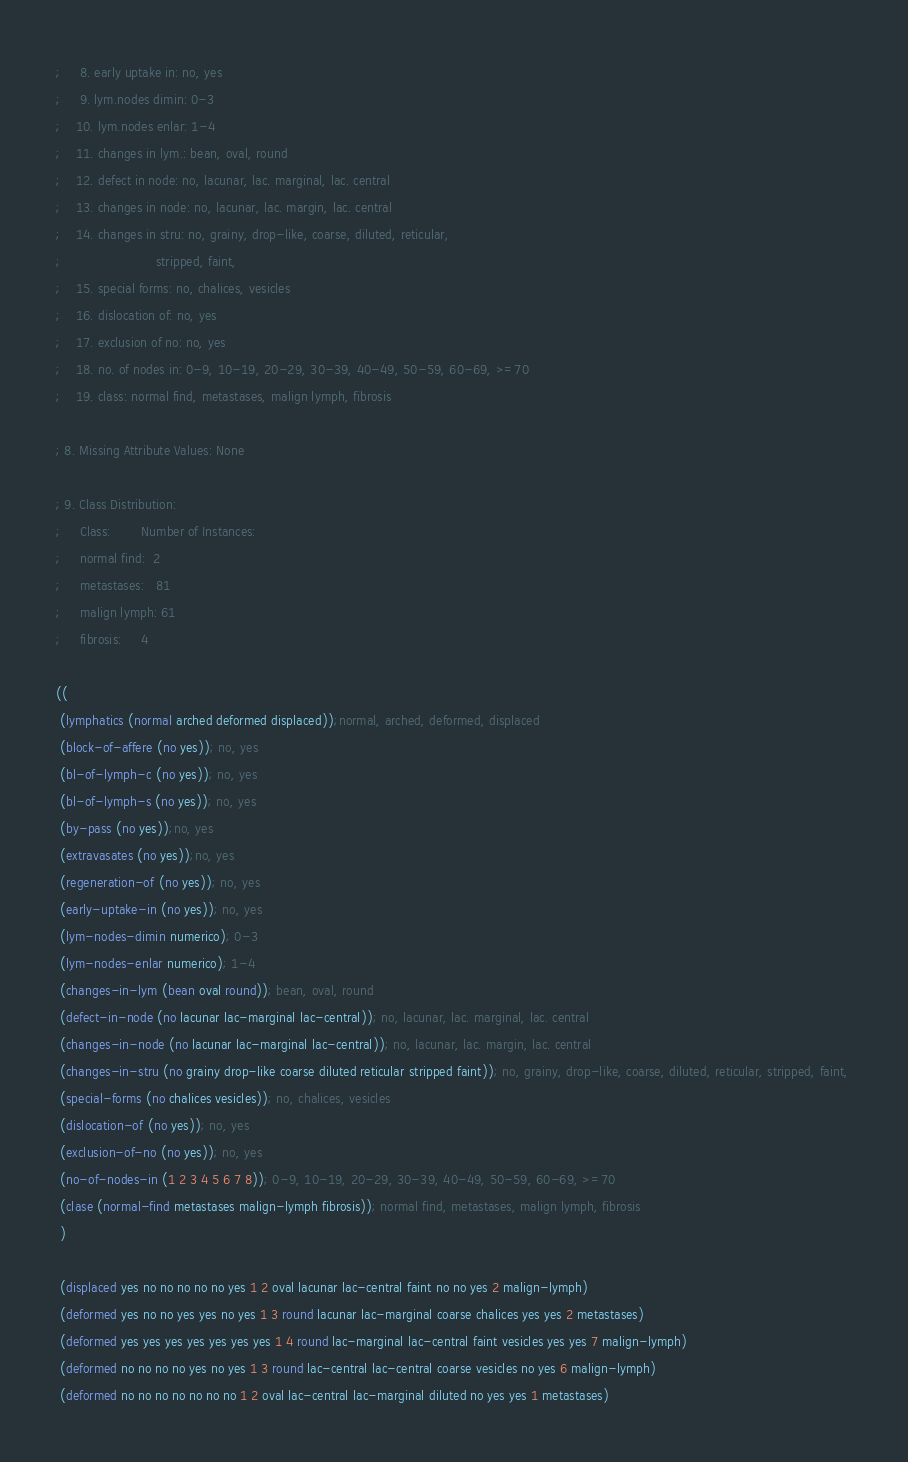Convert code to text. <code><loc_0><loc_0><loc_500><loc_500><_Scheme_>;     8. early uptake in: no, yes
;     9. lym.nodes dimin: 0-3
;    10. lym.nodes enlar: 1-4
;    11. changes in lym.: bean, oval, round
;    12. defect in node: no, lacunar, lac. marginal, lac. central
;    13. changes in node: no, lacunar, lac. margin, lac. central
;    14. changes in stru: no, grainy, drop-like, coarse, diluted, reticular, 
;                         stripped, faint, 
;    15. special forms: no, chalices, vesicles
;    16. dislocation of: no, yes
;    17. exclusion of no: no, yes
;    18. no. of nodes in: 0-9, 10-19, 20-29, 30-39, 40-49, 50-59, 60-69, >=70
;    19. class: normal find, metastases, malign lymph, fibrosis

; 8. Missing Attribute Values: None

; 9. Class Distribution: 
;     Class:        Number of Instances:
;     normal find:  2
;     metastases:   81
;     malign lymph: 61
;     fibrosis:     4

((
 (lymphatics (normal arched deformed displaced));normal, arched, deformed, displaced
 (block-of-affere (no yes)); no, yes
 (bl-of-lymph-c (no yes)); no, yes
 (bl-of-lymph-s (no yes)); no, yes
 (by-pass (no yes));no, yes
 (extravasates (no yes));no, yes
 (regeneration-of (no yes)); no, yes
 (early-uptake-in (no yes)); no, yes
 (lym-nodes-dimin numerico); 0-3
 (lym-nodes-enlar numerico); 1-4
 (changes-in-lym (bean oval round)); bean, oval, round
 (defect-in-node (no lacunar lac-marginal lac-central)); no, lacunar, lac. marginal, lac. central
 (changes-in-node (no lacunar lac-marginal lac-central)); no, lacunar, lac. margin, lac. central
 (changes-in-stru (no grainy drop-like coarse diluted reticular stripped faint)); no, grainy, drop-like, coarse, diluted, reticular, stripped, faint, 
 (special-forms (no chalices vesicles)); no, chalices, vesicles
 (dislocation-of (no yes)); no, yes
 (exclusion-of-no (no yes)); no, yes
 (no-of-nodes-in (1 2 3 4 5 6 7 8)); 0-9, 10-19, 20-29, 30-39, 40-49, 50-59, 60-69, >=70
 (clase (normal-find metastases malign-lymph fibrosis)); normal find, metastases, malign lymph, fibrosis
 )

 (displaced yes no no no no no yes 1 2 oval lacunar lac-central faint no no yes 2 malign-lymph)
 (deformed yes no no yes yes no yes 1 3 round lacunar lac-marginal coarse chalices yes yes 2 metastases)
 (deformed yes yes yes yes yes yes yes 1 4 round lac-marginal lac-central faint vesicles yes yes 7 malign-lymph)
 (deformed no no no no yes no yes 1 3 round lac-central lac-central coarse vesicles no yes 6 malign-lymph)
 (deformed no no no no no no no 1 2 oval lac-central lac-marginal diluted no yes yes 1 metastases)</code> 